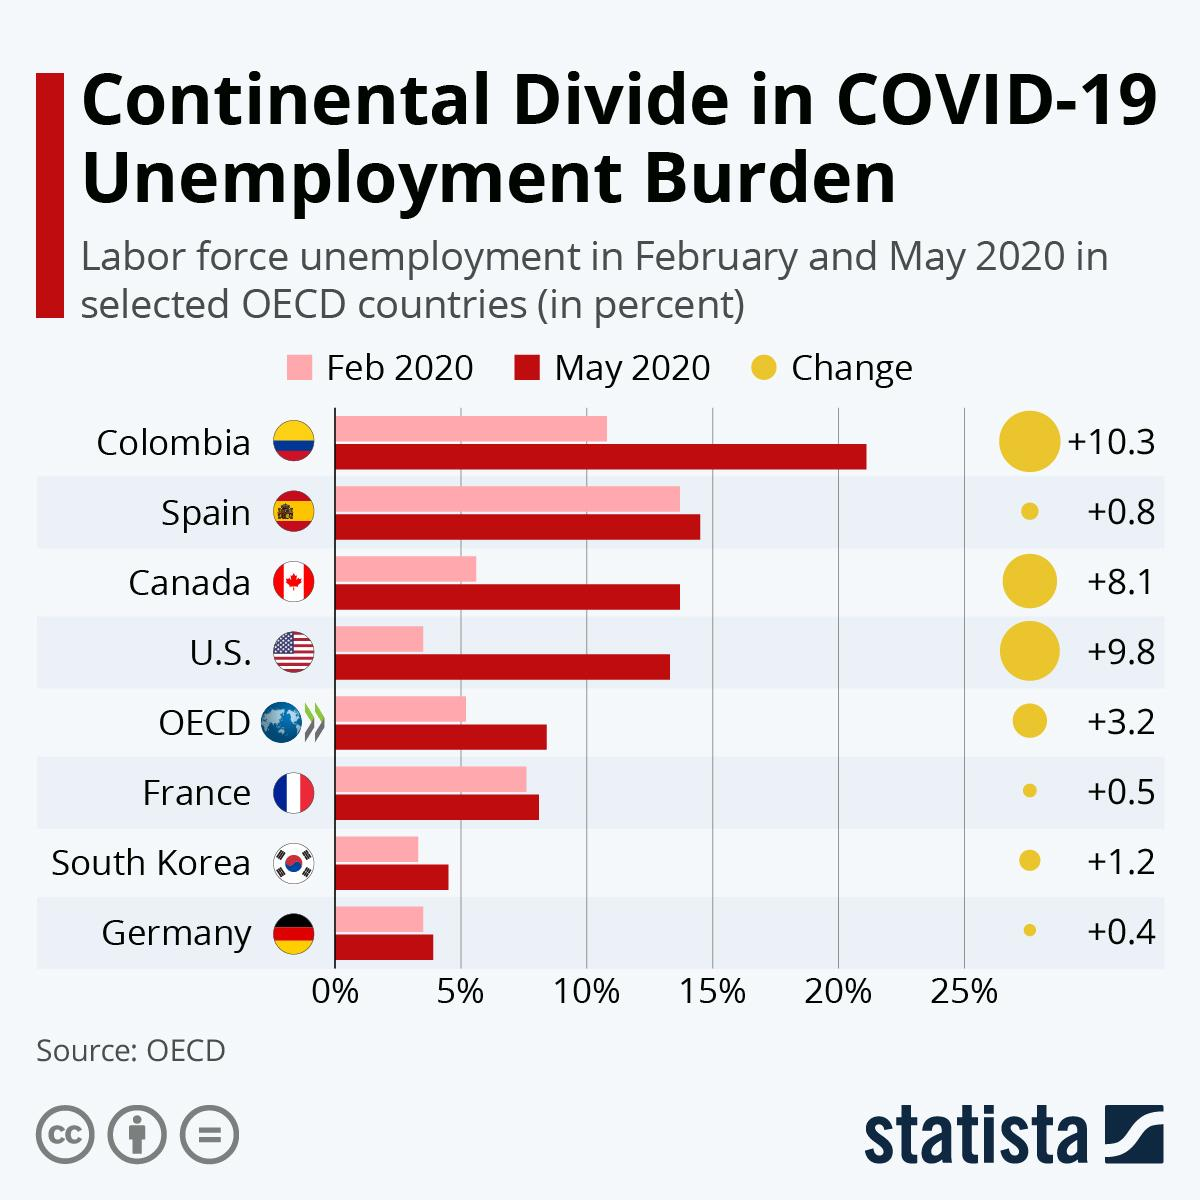Indicate a few pertinent items in this graphic. South Korea and Germany are countries with labor force unemployment rate below 5% In May 2020, Colombia had a labor force unemployment rate that exceeded 20%. Seven OECD member countries are listed. 